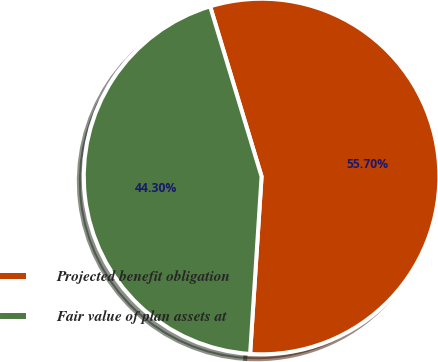Convert chart to OTSL. <chart><loc_0><loc_0><loc_500><loc_500><pie_chart><fcel>Projected benefit obligation<fcel>Fair value of plan assets at<nl><fcel>55.7%<fcel>44.3%<nl></chart> 